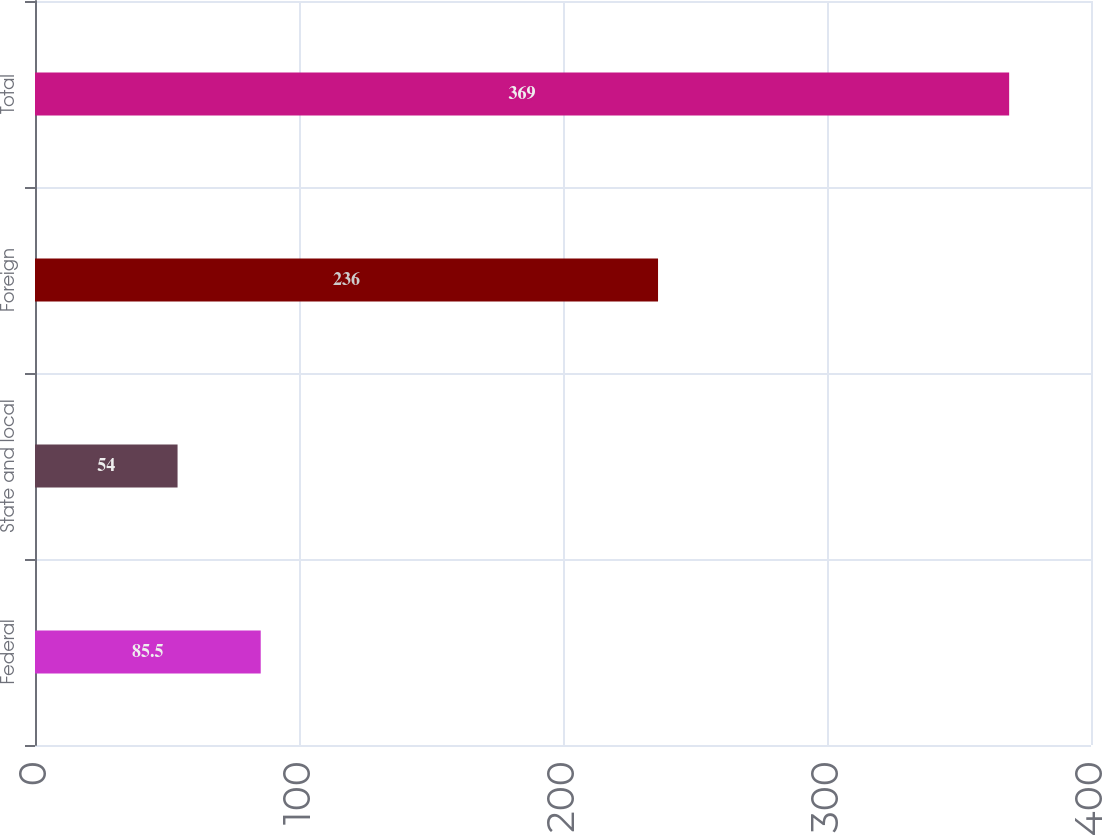<chart> <loc_0><loc_0><loc_500><loc_500><bar_chart><fcel>Federal<fcel>State and local<fcel>Foreign<fcel>Total<nl><fcel>85.5<fcel>54<fcel>236<fcel>369<nl></chart> 